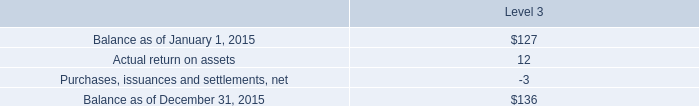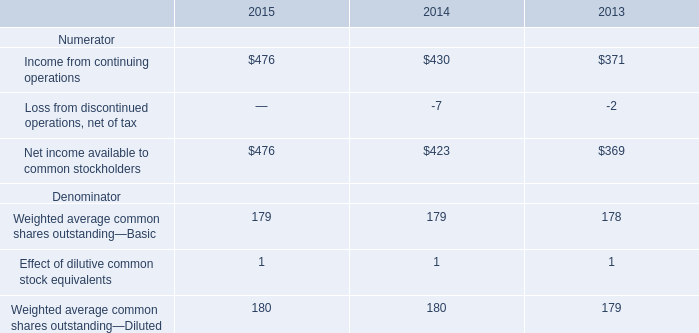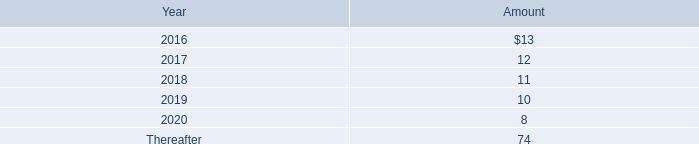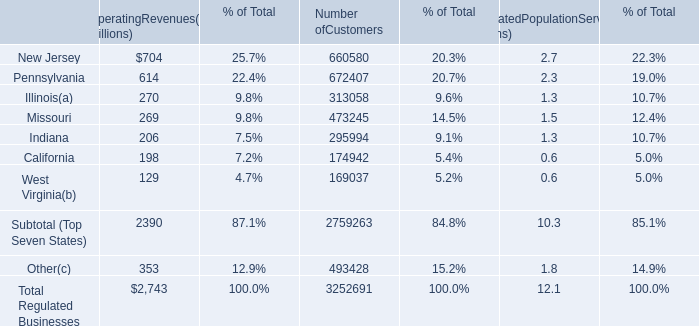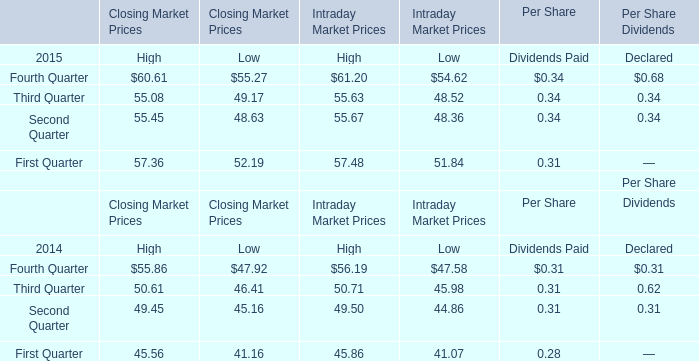what was the amortization expense for the operating leases for facility and equipment from 2015 to 2014 in dollars 
Computations: (22 - 21)
Answer: 1.0. 